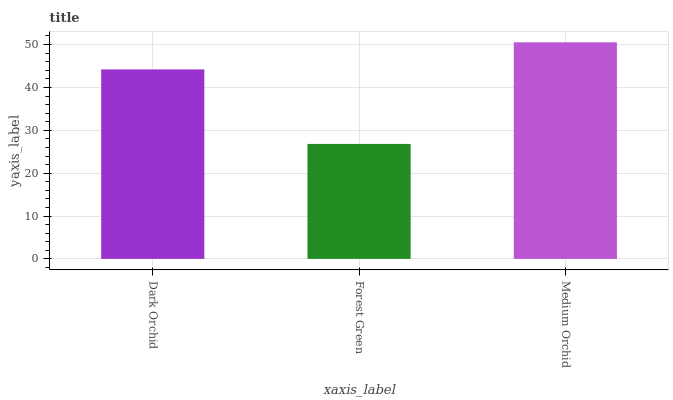Is Medium Orchid the minimum?
Answer yes or no. No. Is Forest Green the maximum?
Answer yes or no. No. Is Medium Orchid greater than Forest Green?
Answer yes or no. Yes. Is Forest Green less than Medium Orchid?
Answer yes or no. Yes. Is Forest Green greater than Medium Orchid?
Answer yes or no. No. Is Medium Orchid less than Forest Green?
Answer yes or no. No. Is Dark Orchid the high median?
Answer yes or no. Yes. Is Dark Orchid the low median?
Answer yes or no. Yes. Is Forest Green the high median?
Answer yes or no. No. Is Medium Orchid the low median?
Answer yes or no. No. 